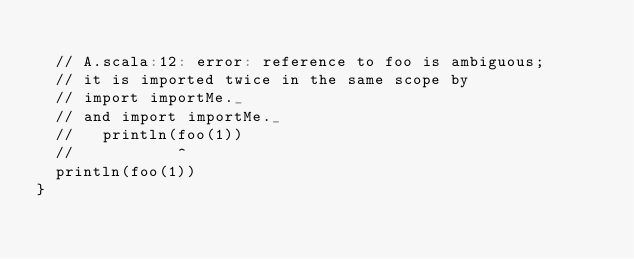<code> <loc_0><loc_0><loc_500><loc_500><_Scala_>
  // A.scala:12: error: reference to foo is ambiguous;
  // it is imported twice in the same scope by
  // import importMe._
  // and import importMe._
  //   println(foo(1))
  //           ^
  println(foo(1))
}
</code> 